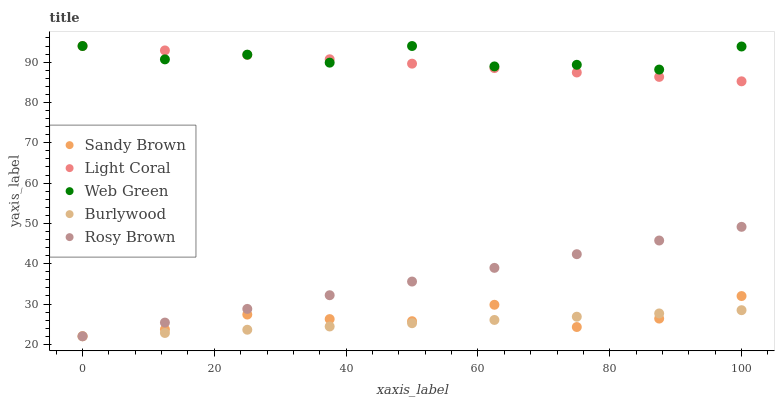Does Burlywood have the minimum area under the curve?
Answer yes or no. Yes. Does Web Green have the maximum area under the curve?
Answer yes or no. Yes. Does Rosy Brown have the minimum area under the curve?
Answer yes or no. No. Does Rosy Brown have the maximum area under the curve?
Answer yes or no. No. Is Burlywood the smoothest?
Answer yes or no. Yes. Is Web Green the roughest?
Answer yes or no. Yes. Is Rosy Brown the smoothest?
Answer yes or no. No. Is Rosy Brown the roughest?
Answer yes or no. No. Does Burlywood have the lowest value?
Answer yes or no. Yes. Does Web Green have the lowest value?
Answer yes or no. No. Does Web Green have the highest value?
Answer yes or no. Yes. Does Rosy Brown have the highest value?
Answer yes or no. No. Is Burlywood less than Web Green?
Answer yes or no. Yes. Is Light Coral greater than Sandy Brown?
Answer yes or no. Yes. Does Rosy Brown intersect Burlywood?
Answer yes or no. Yes. Is Rosy Brown less than Burlywood?
Answer yes or no. No. Is Rosy Brown greater than Burlywood?
Answer yes or no. No. Does Burlywood intersect Web Green?
Answer yes or no. No. 